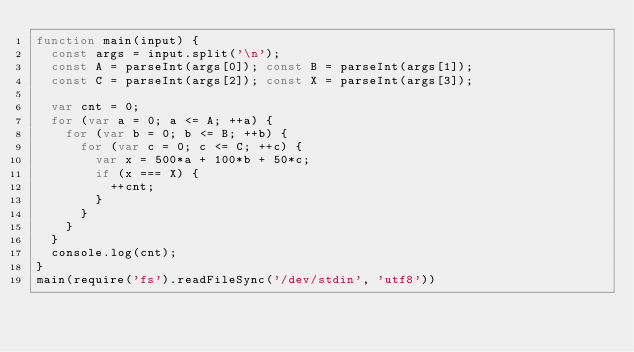<code> <loc_0><loc_0><loc_500><loc_500><_JavaScript_>function main(input) {
  const args = input.split('\n');
  const A = parseInt(args[0]); const B = parseInt(args[1]);
  const C = parseInt(args[2]); const X = parseInt(args[3]);
  
  var cnt = 0;
  for (var a = 0; a <= A; ++a) {
    for (var b = 0; b <= B; ++b) {
      for (var c = 0; c <= C; ++c) {
        var x = 500*a + 100*b + 50*c;
        if (x === X) {
          ++cnt;
        }
      }
    }
  }
  console.log(cnt);
}
main(require('fs').readFileSync('/dev/stdin', 'utf8'))
</code> 